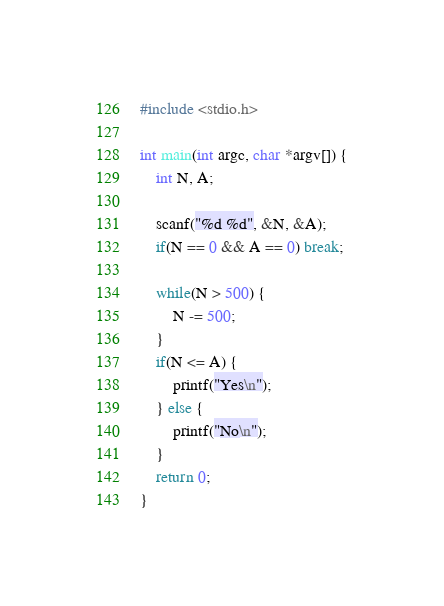Convert code to text. <code><loc_0><loc_0><loc_500><loc_500><_C_>#include <stdio.h>

int main(int argc, char *argv[]) {
	int N, A;
	
	scanf("%d %d", &N, &A);
	if(N == 0 && A == 0) break;
	
	while(N > 500) {
		N -= 500;
	}
	if(N <= A) {
		printf("Yes\n");
	} else {
		printf("No\n");
	}
	return 0;
}</code> 